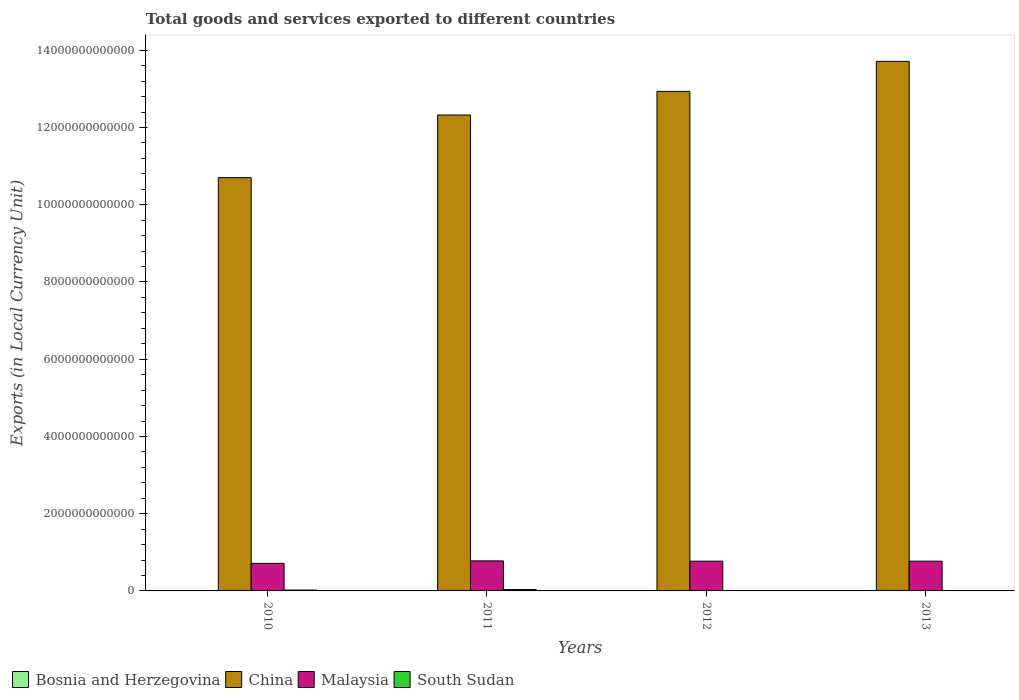How many different coloured bars are there?
Offer a terse response. 4. How many groups of bars are there?
Your answer should be very brief. 4. How many bars are there on the 3rd tick from the left?
Provide a short and direct response. 4. In how many cases, is the number of bars for a given year not equal to the number of legend labels?
Offer a terse response. 0. What is the Amount of goods and services exports in China in 2010?
Offer a very short reply. 1.07e+13. Across all years, what is the maximum Amount of goods and services exports in South Sudan?
Offer a terse response. 3.52e+1. Across all years, what is the minimum Amount of goods and services exports in Malaysia?
Ensure brevity in your answer.  7.14e+11. In which year was the Amount of goods and services exports in South Sudan minimum?
Keep it short and to the point. 2012. What is the total Amount of goods and services exports in Bosnia and Herzegovina in the graph?
Offer a terse response. 3.34e+1. What is the difference between the Amount of goods and services exports in Bosnia and Herzegovina in 2011 and that in 2013?
Keep it short and to the point. -5.88e+08. What is the difference between the Amount of goods and services exports in China in 2011 and the Amount of goods and services exports in Malaysia in 2012?
Give a very brief answer. 1.16e+13. What is the average Amount of goods and services exports in Bosnia and Herzegovina per year?
Make the answer very short. 8.34e+09. In the year 2013, what is the difference between the Amount of goods and services exports in Malaysia and Amount of goods and services exports in China?
Keep it short and to the point. -1.29e+13. In how many years, is the Amount of goods and services exports in China greater than 1600000000000 LCU?
Keep it short and to the point. 4. What is the ratio of the Amount of goods and services exports in South Sudan in 2010 to that in 2011?
Make the answer very short. 0.63. Is the Amount of goods and services exports in Bosnia and Herzegovina in 2011 less than that in 2013?
Give a very brief answer. Yes. Is the difference between the Amount of goods and services exports in Malaysia in 2010 and 2012 greater than the difference between the Amount of goods and services exports in China in 2010 and 2012?
Your answer should be compact. Yes. What is the difference between the highest and the second highest Amount of goods and services exports in Bosnia and Herzegovina?
Offer a very short reply. 5.57e+08. What is the difference between the highest and the lowest Amount of goods and services exports in Bosnia and Herzegovina?
Make the answer very short. 1.46e+09. What does the 1st bar from the left in 2012 represents?
Provide a succinct answer. Bosnia and Herzegovina. What does the 2nd bar from the right in 2013 represents?
Ensure brevity in your answer.  Malaysia. Is it the case that in every year, the sum of the Amount of goods and services exports in Bosnia and Herzegovina and Amount of goods and services exports in South Sudan is greater than the Amount of goods and services exports in China?
Keep it short and to the point. No. How many years are there in the graph?
Your response must be concise. 4. What is the difference between two consecutive major ticks on the Y-axis?
Your answer should be very brief. 2.00e+12. Are the values on the major ticks of Y-axis written in scientific E-notation?
Your answer should be very brief. No. Where does the legend appear in the graph?
Provide a succinct answer. Bottom left. What is the title of the graph?
Give a very brief answer. Total goods and services exported to different countries. Does "Madagascar" appear as one of the legend labels in the graph?
Keep it short and to the point. No. What is the label or title of the Y-axis?
Offer a very short reply. Exports (in Local Currency Unit). What is the Exports (in Local Currency Unit) in Bosnia and Herzegovina in 2010?
Offer a terse response. 7.53e+09. What is the Exports (in Local Currency Unit) of China in 2010?
Your response must be concise. 1.07e+13. What is the Exports (in Local Currency Unit) in Malaysia in 2010?
Your answer should be compact. 7.14e+11. What is the Exports (in Local Currency Unit) of South Sudan in 2010?
Offer a very short reply. 2.23e+1. What is the Exports (in Local Currency Unit) in Bosnia and Herzegovina in 2011?
Give a very brief answer. 8.40e+09. What is the Exports (in Local Currency Unit) of China in 2011?
Ensure brevity in your answer.  1.23e+13. What is the Exports (in Local Currency Unit) of Malaysia in 2011?
Your answer should be compact. 7.77e+11. What is the Exports (in Local Currency Unit) in South Sudan in 2011?
Make the answer very short. 3.52e+1. What is the Exports (in Local Currency Unit) in Bosnia and Herzegovina in 2012?
Ensure brevity in your answer.  8.43e+09. What is the Exports (in Local Currency Unit) in China in 2012?
Make the answer very short. 1.29e+13. What is the Exports (in Local Currency Unit) of Malaysia in 2012?
Your response must be concise. 7.70e+11. What is the Exports (in Local Currency Unit) in South Sudan in 2012?
Make the answer very short. 3.10e+09. What is the Exports (in Local Currency Unit) in Bosnia and Herzegovina in 2013?
Give a very brief answer. 8.99e+09. What is the Exports (in Local Currency Unit) of China in 2013?
Make the answer very short. 1.37e+13. What is the Exports (in Local Currency Unit) in Malaysia in 2013?
Offer a very short reply. 7.70e+11. What is the Exports (in Local Currency Unit) in South Sudan in 2013?
Make the answer very short. 6.33e+09. Across all years, what is the maximum Exports (in Local Currency Unit) of Bosnia and Herzegovina?
Provide a short and direct response. 8.99e+09. Across all years, what is the maximum Exports (in Local Currency Unit) of China?
Keep it short and to the point. 1.37e+13. Across all years, what is the maximum Exports (in Local Currency Unit) of Malaysia?
Your answer should be very brief. 7.77e+11. Across all years, what is the maximum Exports (in Local Currency Unit) in South Sudan?
Your response must be concise. 3.52e+1. Across all years, what is the minimum Exports (in Local Currency Unit) in Bosnia and Herzegovina?
Keep it short and to the point. 7.53e+09. Across all years, what is the minimum Exports (in Local Currency Unit) of China?
Keep it short and to the point. 1.07e+13. Across all years, what is the minimum Exports (in Local Currency Unit) in Malaysia?
Make the answer very short. 7.14e+11. Across all years, what is the minimum Exports (in Local Currency Unit) of South Sudan?
Provide a short and direct response. 3.10e+09. What is the total Exports (in Local Currency Unit) of Bosnia and Herzegovina in the graph?
Provide a succinct answer. 3.34e+1. What is the total Exports (in Local Currency Unit) in China in the graph?
Your answer should be very brief. 4.97e+13. What is the total Exports (in Local Currency Unit) in Malaysia in the graph?
Provide a succinct answer. 3.03e+12. What is the total Exports (in Local Currency Unit) of South Sudan in the graph?
Your answer should be very brief. 6.69e+1. What is the difference between the Exports (in Local Currency Unit) in Bosnia and Herzegovina in 2010 and that in 2011?
Give a very brief answer. -8.71e+08. What is the difference between the Exports (in Local Currency Unit) of China in 2010 and that in 2011?
Offer a terse response. -1.62e+12. What is the difference between the Exports (in Local Currency Unit) in Malaysia in 2010 and that in 2011?
Your answer should be very brief. -6.32e+1. What is the difference between the Exports (in Local Currency Unit) in South Sudan in 2010 and that in 2011?
Make the answer very short. -1.29e+1. What is the difference between the Exports (in Local Currency Unit) in Bosnia and Herzegovina in 2010 and that in 2012?
Your response must be concise. -9.02e+08. What is the difference between the Exports (in Local Currency Unit) in China in 2010 and that in 2012?
Ensure brevity in your answer.  -2.23e+12. What is the difference between the Exports (in Local Currency Unit) of Malaysia in 2010 and that in 2012?
Your response must be concise. -5.61e+1. What is the difference between the Exports (in Local Currency Unit) of South Sudan in 2010 and that in 2012?
Provide a succinct answer. 1.92e+1. What is the difference between the Exports (in Local Currency Unit) of Bosnia and Herzegovina in 2010 and that in 2013?
Make the answer very short. -1.46e+09. What is the difference between the Exports (in Local Currency Unit) of China in 2010 and that in 2013?
Ensure brevity in your answer.  -3.01e+12. What is the difference between the Exports (in Local Currency Unit) in Malaysia in 2010 and that in 2013?
Ensure brevity in your answer.  -5.63e+1. What is the difference between the Exports (in Local Currency Unit) of South Sudan in 2010 and that in 2013?
Give a very brief answer. 1.59e+1. What is the difference between the Exports (in Local Currency Unit) of Bosnia and Herzegovina in 2011 and that in 2012?
Offer a very short reply. -3.08e+07. What is the difference between the Exports (in Local Currency Unit) in China in 2011 and that in 2012?
Ensure brevity in your answer.  -6.12e+11. What is the difference between the Exports (in Local Currency Unit) of Malaysia in 2011 and that in 2012?
Give a very brief answer. 7.10e+09. What is the difference between the Exports (in Local Currency Unit) of South Sudan in 2011 and that in 2012?
Your answer should be very brief. 3.21e+1. What is the difference between the Exports (in Local Currency Unit) of Bosnia and Herzegovina in 2011 and that in 2013?
Keep it short and to the point. -5.88e+08. What is the difference between the Exports (in Local Currency Unit) of China in 2011 and that in 2013?
Your answer should be compact. -1.39e+12. What is the difference between the Exports (in Local Currency Unit) in Malaysia in 2011 and that in 2013?
Your answer should be compact. 6.94e+09. What is the difference between the Exports (in Local Currency Unit) of South Sudan in 2011 and that in 2013?
Offer a very short reply. 2.89e+1. What is the difference between the Exports (in Local Currency Unit) in Bosnia and Herzegovina in 2012 and that in 2013?
Your answer should be compact. -5.57e+08. What is the difference between the Exports (in Local Currency Unit) of China in 2012 and that in 2013?
Make the answer very short. -7.77e+11. What is the difference between the Exports (in Local Currency Unit) in Malaysia in 2012 and that in 2013?
Your response must be concise. -1.66e+08. What is the difference between the Exports (in Local Currency Unit) of South Sudan in 2012 and that in 2013?
Provide a short and direct response. -3.24e+09. What is the difference between the Exports (in Local Currency Unit) in Bosnia and Herzegovina in 2010 and the Exports (in Local Currency Unit) in China in 2011?
Keep it short and to the point. -1.23e+13. What is the difference between the Exports (in Local Currency Unit) in Bosnia and Herzegovina in 2010 and the Exports (in Local Currency Unit) in Malaysia in 2011?
Your answer should be very brief. -7.70e+11. What is the difference between the Exports (in Local Currency Unit) of Bosnia and Herzegovina in 2010 and the Exports (in Local Currency Unit) of South Sudan in 2011?
Keep it short and to the point. -2.77e+1. What is the difference between the Exports (in Local Currency Unit) of China in 2010 and the Exports (in Local Currency Unit) of Malaysia in 2011?
Your response must be concise. 9.92e+12. What is the difference between the Exports (in Local Currency Unit) of China in 2010 and the Exports (in Local Currency Unit) of South Sudan in 2011?
Ensure brevity in your answer.  1.07e+13. What is the difference between the Exports (in Local Currency Unit) of Malaysia in 2010 and the Exports (in Local Currency Unit) of South Sudan in 2011?
Keep it short and to the point. 6.79e+11. What is the difference between the Exports (in Local Currency Unit) of Bosnia and Herzegovina in 2010 and the Exports (in Local Currency Unit) of China in 2012?
Make the answer very short. -1.29e+13. What is the difference between the Exports (in Local Currency Unit) in Bosnia and Herzegovina in 2010 and the Exports (in Local Currency Unit) in Malaysia in 2012?
Provide a succinct answer. -7.63e+11. What is the difference between the Exports (in Local Currency Unit) of Bosnia and Herzegovina in 2010 and the Exports (in Local Currency Unit) of South Sudan in 2012?
Your answer should be compact. 4.44e+09. What is the difference between the Exports (in Local Currency Unit) of China in 2010 and the Exports (in Local Currency Unit) of Malaysia in 2012?
Your answer should be very brief. 9.93e+12. What is the difference between the Exports (in Local Currency Unit) in China in 2010 and the Exports (in Local Currency Unit) in South Sudan in 2012?
Give a very brief answer. 1.07e+13. What is the difference between the Exports (in Local Currency Unit) in Malaysia in 2010 and the Exports (in Local Currency Unit) in South Sudan in 2012?
Make the answer very short. 7.11e+11. What is the difference between the Exports (in Local Currency Unit) in Bosnia and Herzegovina in 2010 and the Exports (in Local Currency Unit) in China in 2013?
Make the answer very short. -1.37e+13. What is the difference between the Exports (in Local Currency Unit) in Bosnia and Herzegovina in 2010 and the Exports (in Local Currency Unit) in Malaysia in 2013?
Provide a short and direct response. -7.63e+11. What is the difference between the Exports (in Local Currency Unit) in Bosnia and Herzegovina in 2010 and the Exports (in Local Currency Unit) in South Sudan in 2013?
Ensure brevity in your answer.  1.20e+09. What is the difference between the Exports (in Local Currency Unit) in China in 2010 and the Exports (in Local Currency Unit) in Malaysia in 2013?
Provide a short and direct response. 9.93e+12. What is the difference between the Exports (in Local Currency Unit) in China in 2010 and the Exports (in Local Currency Unit) in South Sudan in 2013?
Provide a short and direct response. 1.07e+13. What is the difference between the Exports (in Local Currency Unit) of Malaysia in 2010 and the Exports (in Local Currency Unit) of South Sudan in 2013?
Offer a terse response. 7.08e+11. What is the difference between the Exports (in Local Currency Unit) of Bosnia and Herzegovina in 2011 and the Exports (in Local Currency Unit) of China in 2012?
Your response must be concise. -1.29e+13. What is the difference between the Exports (in Local Currency Unit) of Bosnia and Herzegovina in 2011 and the Exports (in Local Currency Unit) of Malaysia in 2012?
Give a very brief answer. -7.62e+11. What is the difference between the Exports (in Local Currency Unit) of Bosnia and Herzegovina in 2011 and the Exports (in Local Currency Unit) of South Sudan in 2012?
Your answer should be very brief. 5.31e+09. What is the difference between the Exports (in Local Currency Unit) in China in 2011 and the Exports (in Local Currency Unit) in Malaysia in 2012?
Your answer should be very brief. 1.16e+13. What is the difference between the Exports (in Local Currency Unit) of China in 2011 and the Exports (in Local Currency Unit) of South Sudan in 2012?
Offer a very short reply. 1.23e+13. What is the difference between the Exports (in Local Currency Unit) in Malaysia in 2011 and the Exports (in Local Currency Unit) in South Sudan in 2012?
Give a very brief answer. 7.74e+11. What is the difference between the Exports (in Local Currency Unit) of Bosnia and Herzegovina in 2011 and the Exports (in Local Currency Unit) of China in 2013?
Your answer should be compact. -1.37e+13. What is the difference between the Exports (in Local Currency Unit) of Bosnia and Herzegovina in 2011 and the Exports (in Local Currency Unit) of Malaysia in 2013?
Ensure brevity in your answer.  -7.62e+11. What is the difference between the Exports (in Local Currency Unit) in Bosnia and Herzegovina in 2011 and the Exports (in Local Currency Unit) in South Sudan in 2013?
Give a very brief answer. 2.07e+09. What is the difference between the Exports (in Local Currency Unit) in China in 2011 and the Exports (in Local Currency Unit) in Malaysia in 2013?
Make the answer very short. 1.16e+13. What is the difference between the Exports (in Local Currency Unit) of China in 2011 and the Exports (in Local Currency Unit) of South Sudan in 2013?
Give a very brief answer. 1.23e+13. What is the difference between the Exports (in Local Currency Unit) in Malaysia in 2011 and the Exports (in Local Currency Unit) in South Sudan in 2013?
Your answer should be very brief. 7.71e+11. What is the difference between the Exports (in Local Currency Unit) in Bosnia and Herzegovina in 2012 and the Exports (in Local Currency Unit) in China in 2013?
Your answer should be very brief. -1.37e+13. What is the difference between the Exports (in Local Currency Unit) in Bosnia and Herzegovina in 2012 and the Exports (in Local Currency Unit) in Malaysia in 2013?
Ensure brevity in your answer.  -7.62e+11. What is the difference between the Exports (in Local Currency Unit) in Bosnia and Herzegovina in 2012 and the Exports (in Local Currency Unit) in South Sudan in 2013?
Offer a terse response. 2.10e+09. What is the difference between the Exports (in Local Currency Unit) in China in 2012 and the Exports (in Local Currency Unit) in Malaysia in 2013?
Ensure brevity in your answer.  1.22e+13. What is the difference between the Exports (in Local Currency Unit) of China in 2012 and the Exports (in Local Currency Unit) of South Sudan in 2013?
Your answer should be compact. 1.29e+13. What is the difference between the Exports (in Local Currency Unit) in Malaysia in 2012 and the Exports (in Local Currency Unit) in South Sudan in 2013?
Make the answer very short. 7.64e+11. What is the average Exports (in Local Currency Unit) of Bosnia and Herzegovina per year?
Provide a succinct answer. 8.34e+09. What is the average Exports (in Local Currency Unit) in China per year?
Your answer should be compact. 1.24e+13. What is the average Exports (in Local Currency Unit) in Malaysia per year?
Your response must be concise. 7.58e+11. What is the average Exports (in Local Currency Unit) in South Sudan per year?
Provide a short and direct response. 1.67e+1. In the year 2010, what is the difference between the Exports (in Local Currency Unit) in Bosnia and Herzegovina and Exports (in Local Currency Unit) in China?
Ensure brevity in your answer.  -1.07e+13. In the year 2010, what is the difference between the Exports (in Local Currency Unit) of Bosnia and Herzegovina and Exports (in Local Currency Unit) of Malaysia?
Provide a succinct answer. -7.07e+11. In the year 2010, what is the difference between the Exports (in Local Currency Unit) in Bosnia and Herzegovina and Exports (in Local Currency Unit) in South Sudan?
Provide a succinct answer. -1.47e+1. In the year 2010, what is the difference between the Exports (in Local Currency Unit) in China and Exports (in Local Currency Unit) in Malaysia?
Your response must be concise. 9.99e+12. In the year 2010, what is the difference between the Exports (in Local Currency Unit) in China and Exports (in Local Currency Unit) in South Sudan?
Provide a short and direct response. 1.07e+13. In the year 2010, what is the difference between the Exports (in Local Currency Unit) of Malaysia and Exports (in Local Currency Unit) of South Sudan?
Your answer should be compact. 6.92e+11. In the year 2011, what is the difference between the Exports (in Local Currency Unit) of Bosnia and Herzegovina and Exports (in Local Currency Unit) of China?
Your answer should be compact. -1.23e+13. In the year 2011, what is the difference between the Exports (in Local Currency Unit) of Bosnia and Herzegovina and Exports (in Local Currency Unit) of Malaysia?
Your response must be concise. -7.69e+11. In the year 2011, what is the difference between the Exports (in Local Currency Unit) of Bosnia and Herzegovina and Exports (in Local Currency Unit) of South Sudan?
Your answer should be compact. -2.68e+1. In the year 2011, what is the difference between the Exports (in Local Currency Unit) in China and Exports (in Local Currency Unit) in Malaysia?
Provide a succinct answer. 1.15e+13. In the year 2011, what is the difference between the Exports (in Local Currency Unit) in China and Exports (in Local Currency Unit) in South Sudan?
Offer a very short reply. 1.23e+13. In the year 2011, what is the difference between the Exports (in Local Currency Unit) of Malaysia and Exports (in Local Currency Unit) of South Sudan?
Keep it short and to the point. 7.42e+11. In the year 2012, what is the difference between the Exports (in Local Currency Unit) of Bosnia and Herzegovina and Exports (in Local Currency Unit) of China?
Keep it short and to the point. -1.29e+13. In the year 2012, what is the difference between the Exports (in Local Currency Unit) of Bosnia and Herzegovina and Exports (in Local Currency Unit) of Malaysia?
Your answer should be very brief. -7.62e+11. In the year 2012, what is the difference between the Exports (in Local Currency Unit) of Bosnia and Herzegovina and Exports (in Local Currency Unit) of South Sudan?
Keep it short and to the point. 5.34e+09. In the year 2012, what is the difference between the Exports (in Local Currency Unit) in China and Exports (in Local Currency Unit) in Malaysia?
Ensure brevity in your answer.  1.22e+13. In the year 2012, what is the difference between the Exports (in Local Currency Unit) in China and Exports (in Local Currency Unit) in South Sudan?
Your answer should be very brief. 1.29e+13. In the year 2012, what is the difference between the Exports (in Local Currency Unit) of Malaysia and Exports (in Local Currency Unit) of South Sudan?
Your answer should be compact. 7.67e+11. In the year 2013, what is the difference between the Exports (in Local Currency Unit) in Bosnia and Herzegovina and Exports (in Local Currency Unit) in China?
Offer a terse response. -1.37e+13. In the year 2013, what is the difference between the Exports (in Local Currency Unit) of Bosnia and Herzegovina and Exports (in Local Currency Unit) of Malaysia?
Your response must be concise. -7.61e+11. In the year 2013, what is the difference between the Exports (in Local Currency Unit) of Bosnia and Herzegovina and Exports (in Local Currency Unit) of South Sudan?
Your response must be concise. 2.66e+09. In the year 2013, what is the difference between the Exports (in Local Currency Unit) of China and Exports (in Local Currency Unit) of Malaysia?
Make the answer very short. 1.29e+13. In the year 2013, what is the difference between the Exports (in Local Currency Unit) of China and Exports (in Local Currency Unit) of South Sudan?
Keep it short and to the point. 1.37e+13. In the year 2013, what is the difference between the Exports (in Local Currency Unit) in Malaysia and Exports (in Local Currency Unit) in South Sudan?
Your response must be concise. 7.64e+11. What is the ratio of the Exports (in Local Currency Unit) of Bosnia and Herzegovina in 2010 to that in 2011?
Your answer should be very brief. 0.9. What is the ratio of the Exports (in Local Currency Unit) of China in 2010 to that in 2011?
Provide a short and direct response. 0.87. What is the ratio of the Exports (in Local Currency Unit) in Malaysia in 2010 to that in 2011?
Offer a terse response. 0.92. What is the ratio of the Exports (in Local Currency Unit) of South Sudan in 2010 to that in 2011?
Your answer should be very brief. 0.63. What is the ratio of the Exports (in Local Currency Unit) in Bosnia and Herzegovina in 2010 to that in 2012?
Offer a very short reply. 0.89. What is the ratio of the Exports (in Local Currency Unit) in China in 2010 to that in 2012?
Keep it short and to the point. 0.83. What is the ratio of the Exports (in Local Currency Unit) of Malaysia in 2010 to that in 2012?
Provide a succinct answer. 0.93. What is the ratio of the Exports (in Local Currency Unit) of South Sudan in 2010 to that in 2012?
Make the answer very short. 7.19. What is the ratio of the Exports (in Local Currency Unit) in Bosnia and Herzegovina in 2010 to that in 2013?
Your answer should be very brief. 0.84. What is the ratio of the Exports (in Local Currency Unit) in China in 2010 to that in 2013?
Keep it short and to the point. 0.78. What is the ratio of the Exports (in Local Currency Unit) of Malaysia in 2010 to that in 2013?
Offer a terse response. 0.93. What is the ratio of the Exports (in Local Currency Unit) of South Sudan in 2010 to that in 2013?
Provide a short and direct response. 3.52. What is the ratio of the Exports (in Local Currency Unit) of Bosnia and Herzegovina in 2011 to that in 2012?
Give a very brief answer. 1. What is the ratio of the Exports (in Local Currency Unit) of China in 2011 to that in 2012?
Offer a terse response. 0.95. What is the ratio of the Exports (in Local Currency Unit) of Malaysia in 2011 to that in 2012?
Keep it short and to the point. 1.01. What is the ratio of the Exports (in Local Currency Unit) in South Sudan in 2011 to that in 2012?
Offer a terse response. 11.37. What is the ratio of the Exports (in Local Currency Unit) in Bosnia and Herzegovina in 2011 to that in 2013?
Make the answer very short. 0.93. What is the ratio of the Exports (in Local Currency Unit) of China in 2011 to that in 2013?
Your answer should be compact. 0.9. What is the ratio of the Exports (in Local Currency Unit) of South Sudan in 2011 to that in 2013?
Make the answer very short. 5.56. What is the ratio of the Exports (in Local Currency Unit) in Bosnia and Herzegovina in 2012 to that in 2013?
Your answer should be compact. 0.94. What is the ratio of the Exports (in Local Currency Unit) of China in 2012 to that in 2013?
Your answer should be compact. 0.94. What is the ratio of the Exports (in Local Currency Unit) in South Sudan in 2012 to that in 2013?
Provide a succinct answer. 0.49. What is the difference between the highest and the second highest Exports (in Local Currency Unit) of Bosnia and Herzegovina?
Ensure brevity in your answer.  5.57e+08. What is the difference between the highest and the second highest Exports (in Local Currency Unit) in China?
Give a very brief answer. 7.77e+11. What is the difference between the highest and the second highest Exports (in Local Currency Unit) of Malaysia?
Give a very brief answer. 6.94e+09. What is the difference between the highest and the second highest Exports (in Local Currency Unit) in South Sudan?
Offer a very short reply. 1.29e+1. What is the difference between the highest and the lowest Exports (in Local Currency Unit) in Bosnia and Herzegovina?
Provide a succinct answer. 1.46e+09. What is the difference between the highest and the lowest Exports (in Local Currency Unit) of China?
Ensure brevity in your answer.  3.01e+12. What is the difference between the highest and the lowest Exports (in Local Currency Unit) in Malaysia?
Keep it short and to the point. 6.32e+1. What is the difference between the highest and the lowest Exports (in Local Currency Unit) in South Sudan?
Give a very brief answer. 3.21e+1. 